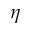<formula> <loc_0><loc_0><loc_500><loc_500>\eta</formula> 